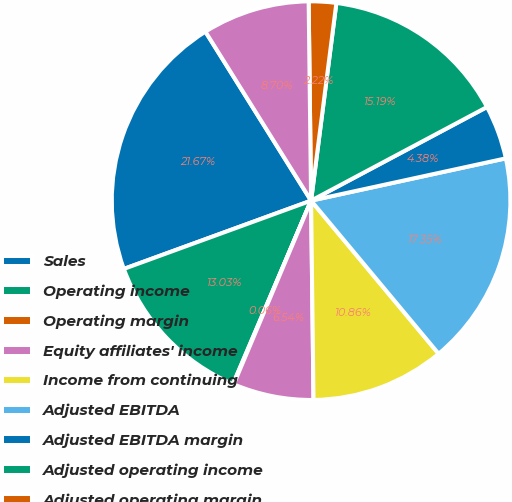<chart> <loc_0><loc_0><loc_500><loc_500><pie_chart><fcel>Sales<fcel>Operating income<fcel>Operating margin<fcel>Equity affiliates' income<fcel>Income from continuing<fcel>Adjusted EBITDA<fcel>Adjusted EBITDA margin<fcel>Adjusted operating income<fcel>Adjusted operating margin<fcel>Adjusted equity affiliates'<nl><fcel>21.67%<fcel>13.03%<fcel>0.06%<fcel>6.54%<fcel>10.86%<fcel>17.35%<fcel>4.38%<fcel>15.19%<fcel>2.22%<fcel>8.7%<nl></chart> 